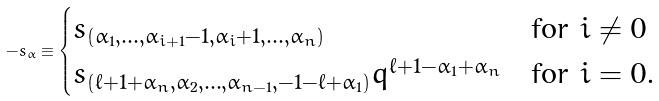<formula> <loc_0><loc_0><loc_500><loc_500>- s _ { \alpha } \equiv \begin{cases} s _ { ( \alpha _ { 1 } , \dots , \alpha _ { i + 1 } - 1 , \alpha _ { i } + 1 , \dots , \alpha _ { n } ) } & \text {for $i\not=0$} \\ s _ { ( \ell + 1 + \alpha _ { n } , \alpha _ { 2 } , \dots , \alpha _ { n - 1 } , - 1 - \ell + \alpha _ { 1 } ) } q ^ { \ell + 1 - \alpha _ { 1 } + \alpha _ { n } } & \text {for $i=0$.} \end{cases}</formula> 